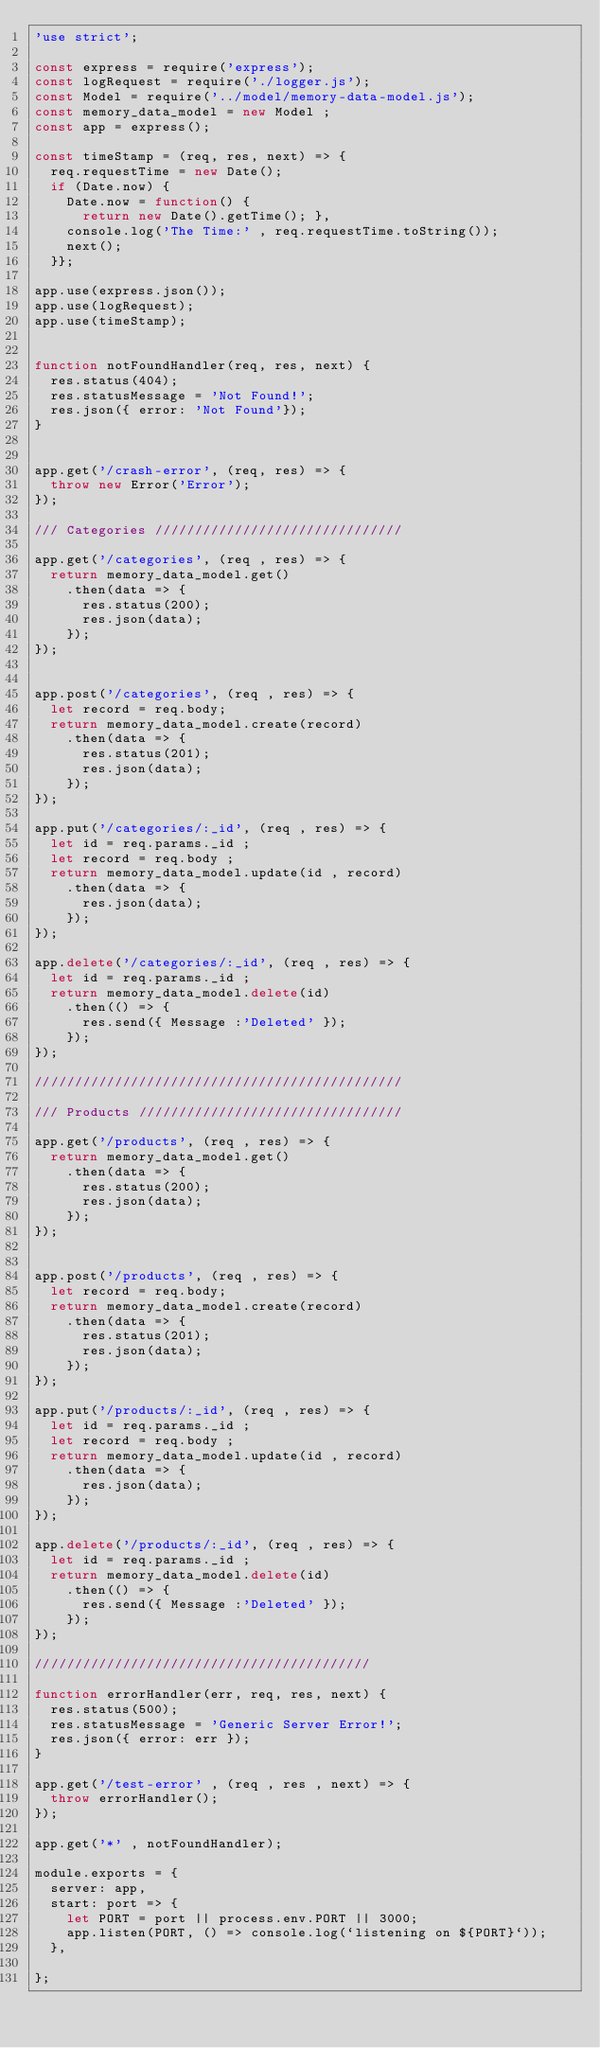Convert code to text. <code><loc_0><loc_0><loc_500><loc_500><_JavaScript_>'use strict';

const express = require('express');
const logRequest = require('./logger.js');
const Model = require('../model/memory-data-model.js');
const memory_data_model = new Model ;
const app = express();

const timeStamp = (req, res, next) => {
  req.requestTime = new Date();
  if (Date.now) { 
    Date.now = function() { 
      return new Date().getTime(); },
    console.log('The Time:' , req.requestTime.toString());
    next();
  }};

app.use(express.json());
app.use(logRequest);
app.use(timeStamp);


function notFoundHandler(req, res, next) {
  res.status(404);
  res.statusMessage = 'Not Found!';
  res.json({ error: 'Not Found'});
}


app.get('/crash-error', (req, res) => {
  throw new Error('Error');
});

/// Categories ///////////////////////////////

app.get('/categories', (req , res) => {
  return memory_data_model.get()
    .then(data => {
      res.status(200);
      res.json(data);
    });
});


app.post('/categories', (req , res) => {
  let record = req.body;
  return memory_data_model.create(record)
    .then(data => {
      res.status(201);
      res.json(data);
    });
});

app.put('/categories/:_id', (req , res) => {
  let id = req.params._id ;
  let record = req.body ;
  return memory_data_model.update(id , record)
    .then(data => {
      res.json(data);
    });
});

app.delete('/categories/:_id', (req , res) => {
  let id = req.params._id ;
  return memory_data_model.delete(id)
    .then(() => {
      res.send({ Message :'Deleted' });
    });
});

//////////////////////////////////////////////

/// Products /////////////////////////////////

app.get('/products', (req , res) => {
  return memory_data_model.get()
    .then(data => {
      res.status(200);
      res.json(data);
    });
});


app.post('/products', (req , res) => {
  let record = req.body;
  return memory_data_model.create(record)
    .then(data => {
      res.status(201);
      res.json(data);
    });
});

app.put('/products/:_id', (req , res) => {
  let id = req.params._id ;
  let record = req.body ;
  return memory_data_model.update(id , record)
    .then(data => {
      res.json(data);
    });
});

app.delete('/products/:_id', (req , res) => {
  let id = req.params._id ;
  return memory_data_model.delete(id)
    .then(() => {
      res.send({ Message :'Deleted' });
    });
});

//////////////////////////////////////////

function errorHandler(err, req, res, next) {
  res.status(500);
  res.statusMessage = 'Generic Server Error!';
  res.json({ error: err });
}

app.get('/test-error' , (req , res , next) => {
  throw errorHandler();
});

app.get('*' , notFoundHandler);

module.exports = {
  server: app,
  start: port => {
    let PORT = port || process.env.PORT || 3000;
    app.listen(PORT, () => console.log(`listening on ${PORT}`));
  },

};</code> 